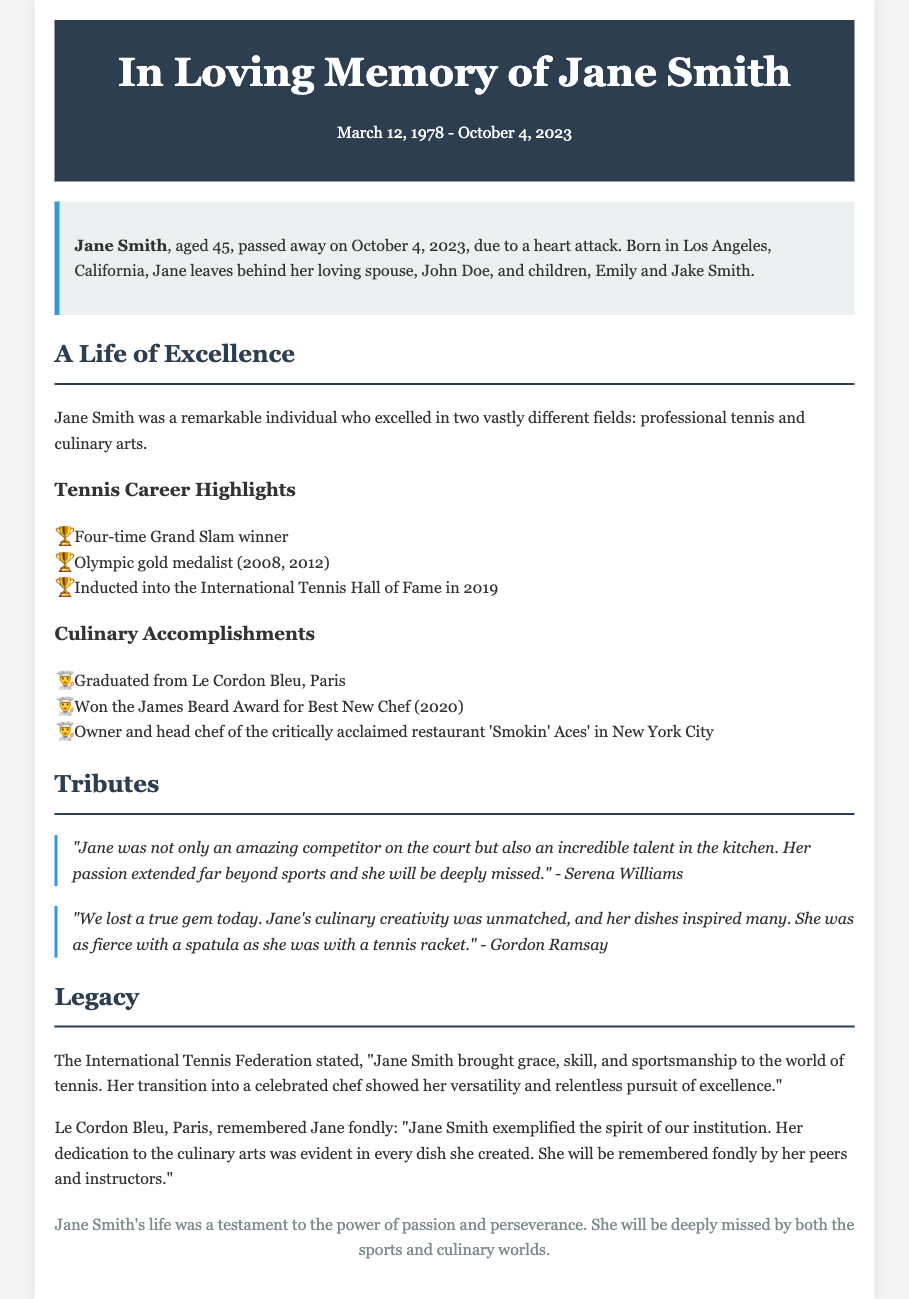what date did Jane Smith pass away? The document states that Jane Smith passed away on October 4, 2023.
Answer: October 4, 2023 who was Jane's spouse? The document mentions her loving spouse as John Doe.
Answer: John Doe how many Olympic gold medals did Jane win? The document lists Jane as an Olympic gold medalist for the years 2008 and 2012, meaning she won two gold medals.
Answer: Two what award did Jane win in 2020? According to the document, she won the James Beard Award for Best New Chef in 2020.
Answer: James Beard Award for Best New Chef who stated that Jane brought grace and skill to tennis? The International Tennis Federation made this statement about Jane.
Answer: International Tennis Federation how many Grand Slam titles did Jane win? The document specifies that she was a four-time Grand Slam winner.
Answer: Four what restaurant did Jane own? The document states she was the owner and head chef of 'Smokin' Aces' in New York City.
Answer: Smokin' Aces which institution graduated Jane? The document notes that Jane graduated from Le Cordon Bleu in Paris.
Answer: Le Cordon Bleu who called Jane's culinary creativity unmatched? The document quotes Gordon Ramsay as stating Jane's culinary creativity was unmatched.
Answer: Gordon Ramsay 